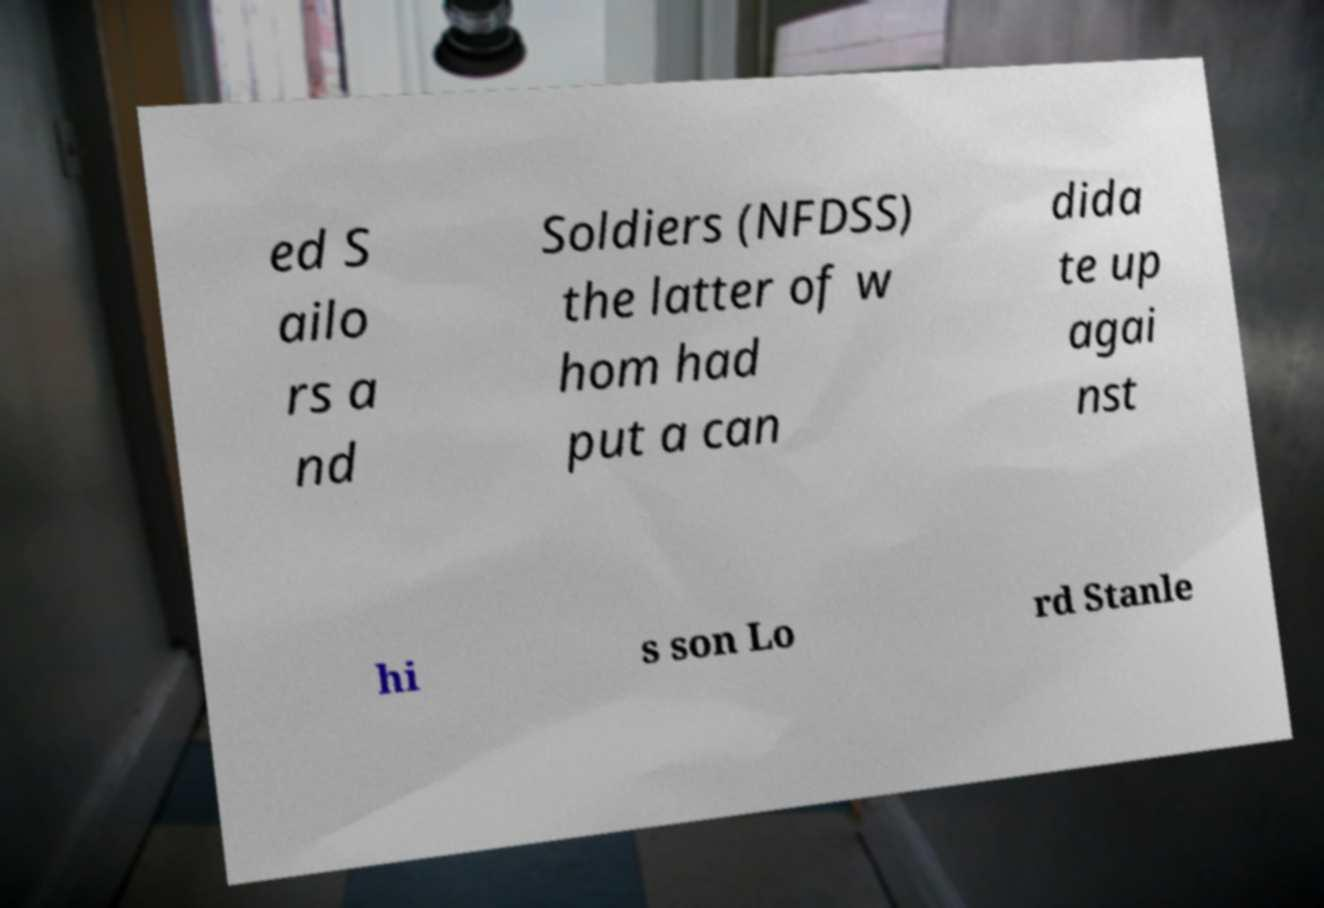Could you extract and type out the text from this image? ed S ailo rs a nd Soldiers (NFDSS) the latter of w hom had put a can dida te up agai nst hi s son Lo rd Stanle 